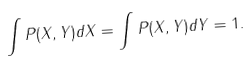Convert formula to latex. <formula><loc_0><loc_0><loc_500><loc_500>\int P ( X , Y ) d X = \int P ( X , Y ) d Y = 1 .</formula> 